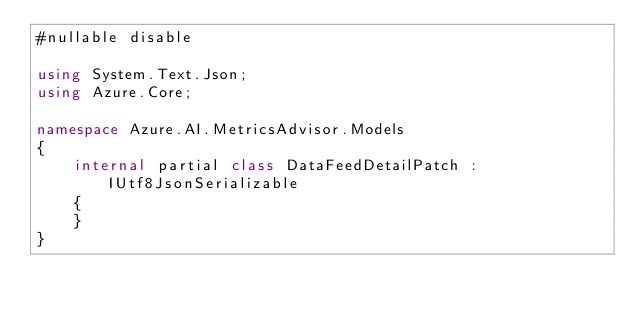Convert code to text. <code><loc_0><loc_0><loc_500><loc_500><_C#_>#nullable disable

using System.Text.Json;
using Azure.Core;

namespace Azure.AI.MetricsAdvisor.Models
{
    internal partial class DataFeedDetailPatch : IUtf8JsonSerializable
    {
    }
}
</code> 